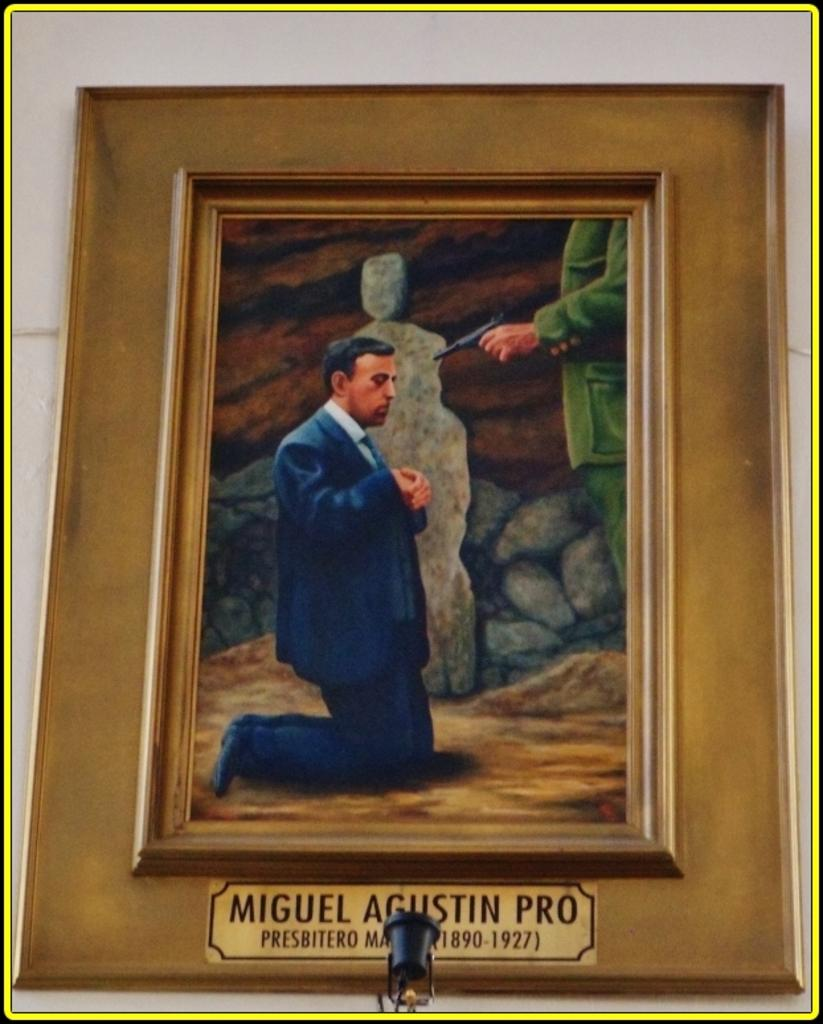What object is present in the image that typically holds a picture? There is a photo frame in the image that typically holds a picture. What is depicted in the photo frame? The photo frame contains a picture of a person. Where is the photo frame located in the image? The photo frame is on a wall. What additional information is present at the bottom of the photo frame? There is text and numbers at the bottom of the photo frame. What type of crime is being committed in the image? There is no indication of a crime being committed in the image; it features a photo frame with a picture of a person on a wall. Is there a lawyer present in the image? There is no lawyer present in the image. 